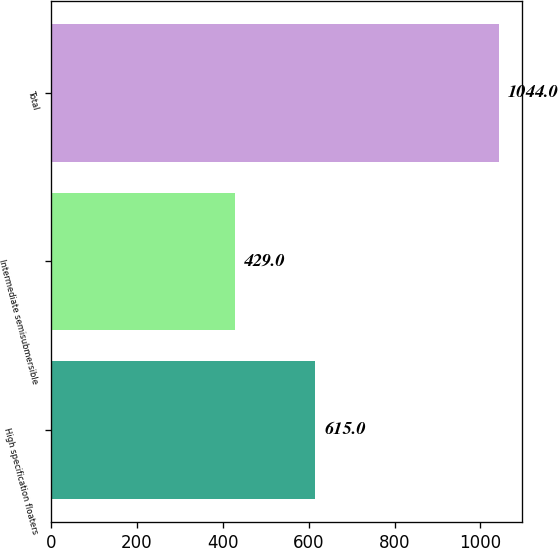Convert chart to OTSL. <chart><loc_0><loc_0><loc_500><loc_500><bar_chart><fcel>High specification floaters<fcel>Intermediate semisubmersible<fcel>Total<nl><fcel>615<fcel>429<fcel>1044<nl></chart> 